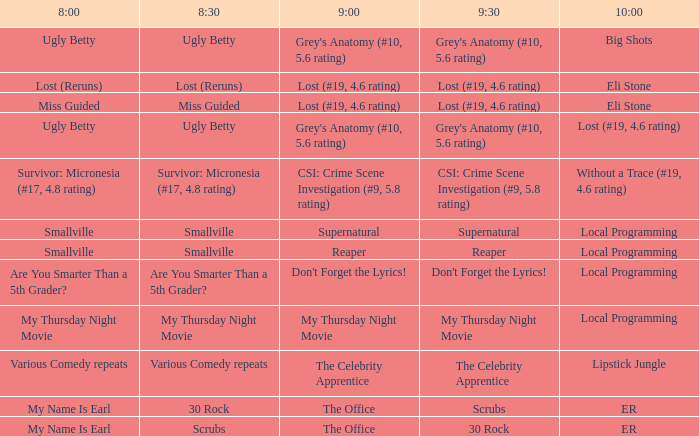What is at 9:30 when at 8:30 it is scrubs? 30 Rock. 